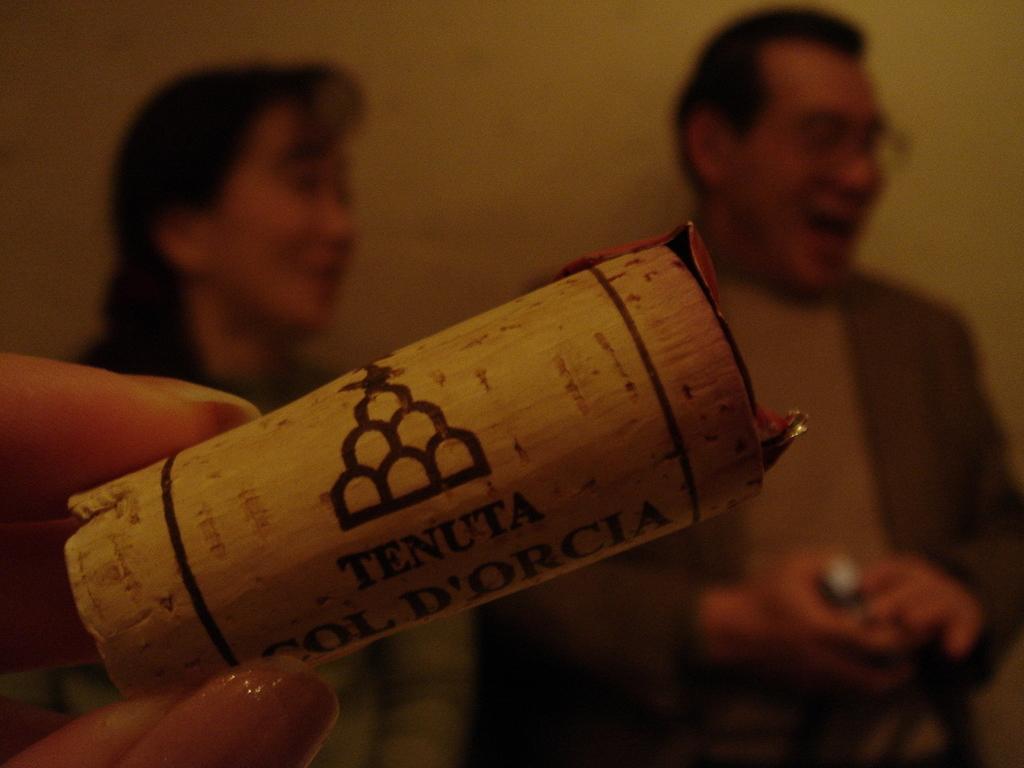Describe this image in one or two sentences. In this image in the center there is a paper with some text written on it. In the background there are persons smiling. On the left side there is a hand of the person visible. 